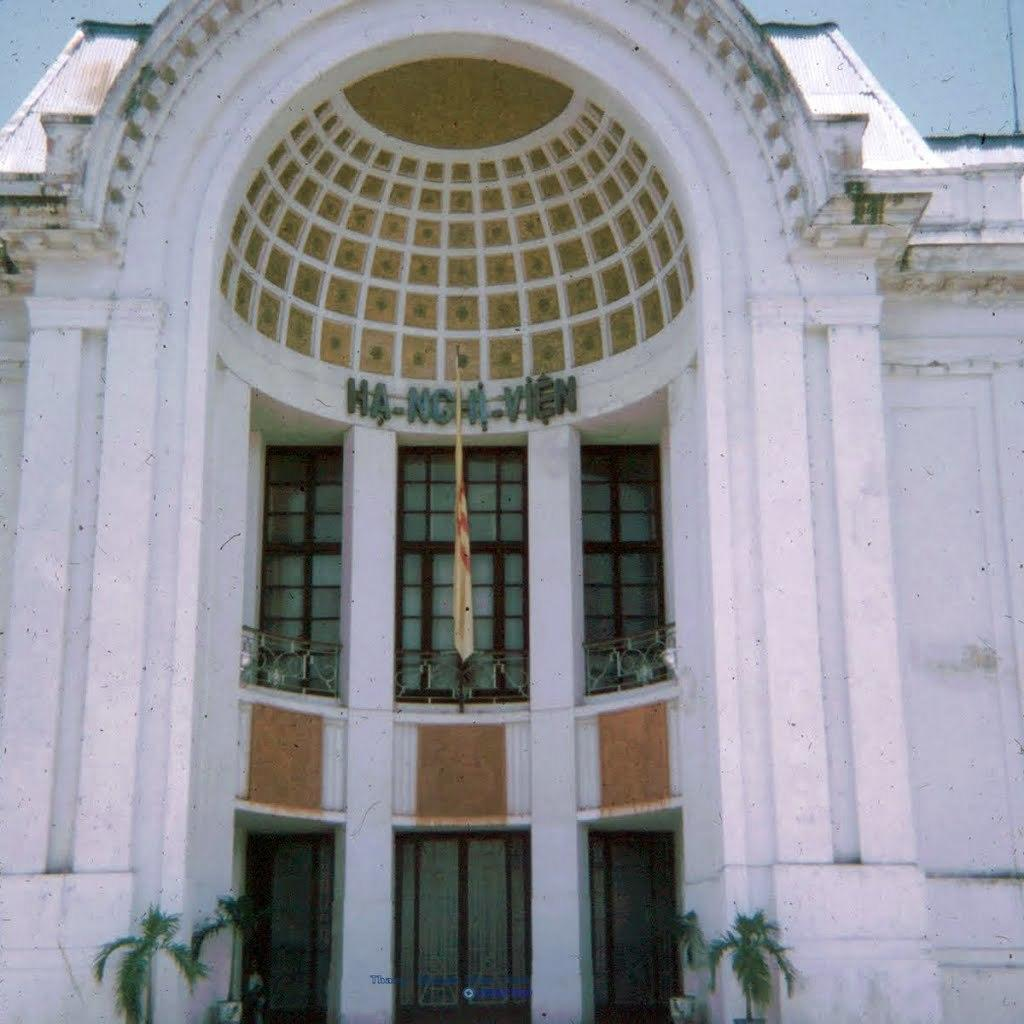What type of structure is visible in the image? There is a building in the image. How can the building be identified? The building has a name board. What is located near the building? There is a flag near the building. How can one enter the building? The building has a door. What type of vegetation is present in front of the building? There are plants in front of the building. Can you see any grass growing on the icicles in the image? There are no icicles present in the image, and therefore no grass growing on them. 